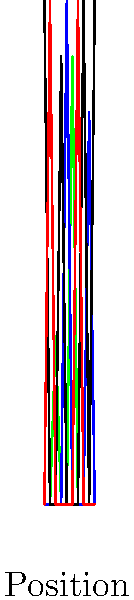Analyze the DNA sequencing chromatogram above. At position 5, there appears to be a discrepancy in the expected sequence. What type of mutation is most likely represented by this anomaly, and what is the expected impact on the resulting protein? 1. Observe the chromatogram:
   - The sequence appears to be: G-T-A-G-C-A-T-G-C-G

2. Focus on position 5:
   - There's a strong blue peak (C) with a small underlying green peak (A)

3. Interpret the anomaly:
   - This pattern suggests a heterozygous point mutation
   - One allele has C, while the other has A at this position

4. Identify the mutation type:
   - This is likely a missense mutation (single nucleotide substitution)

5. Consider the genetic code:
   - Without knowing the reading frame, we can't determine the exact codon change
   - However, a C to A mutation often results in an amino acid change

6. Assess the potential impact:
   - Missense mutations can lead to:
     a) No significant change (silent mutation)
     b) Altered protein function (conservative or non-conservative change)
     c) Loss of protein function

7. Conclude:
   - This is likely a heterozygous missense mutation
   - It may affect protein function, depending on the specific amino acid change
Answer: Heterozygous missense mutation; potential altered protein function 